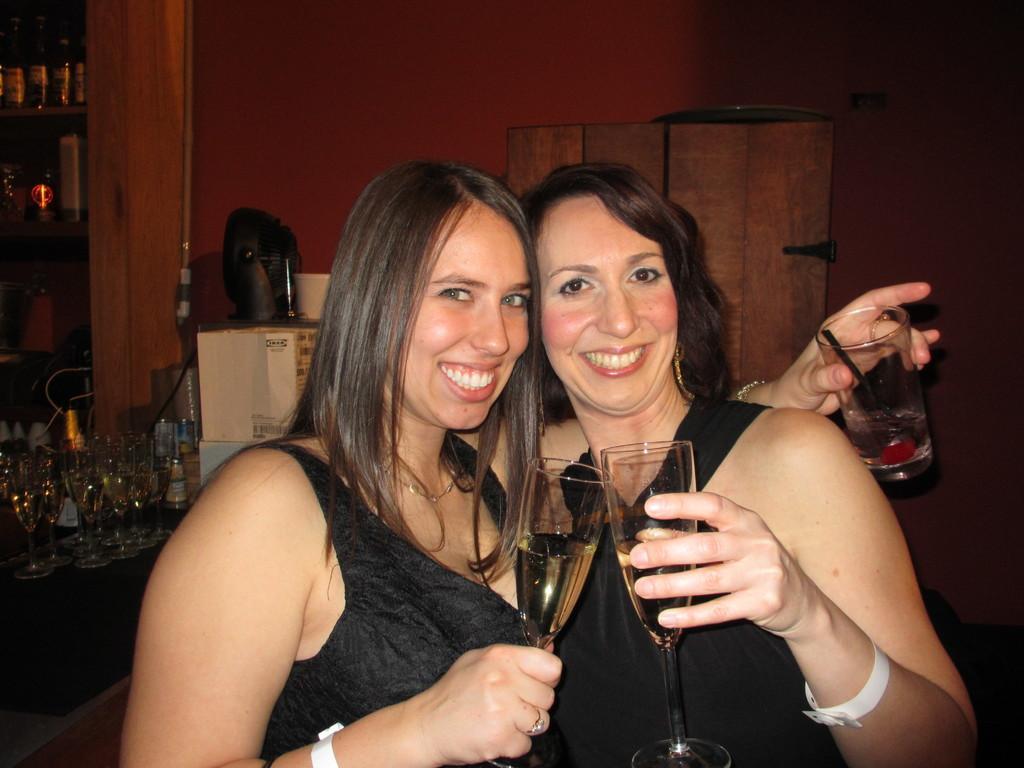Describe this image in one or two sentences. this picture show two women standing with a smile on the faces holding wine glasses in their hand and we see few bottles and glasses on their back 